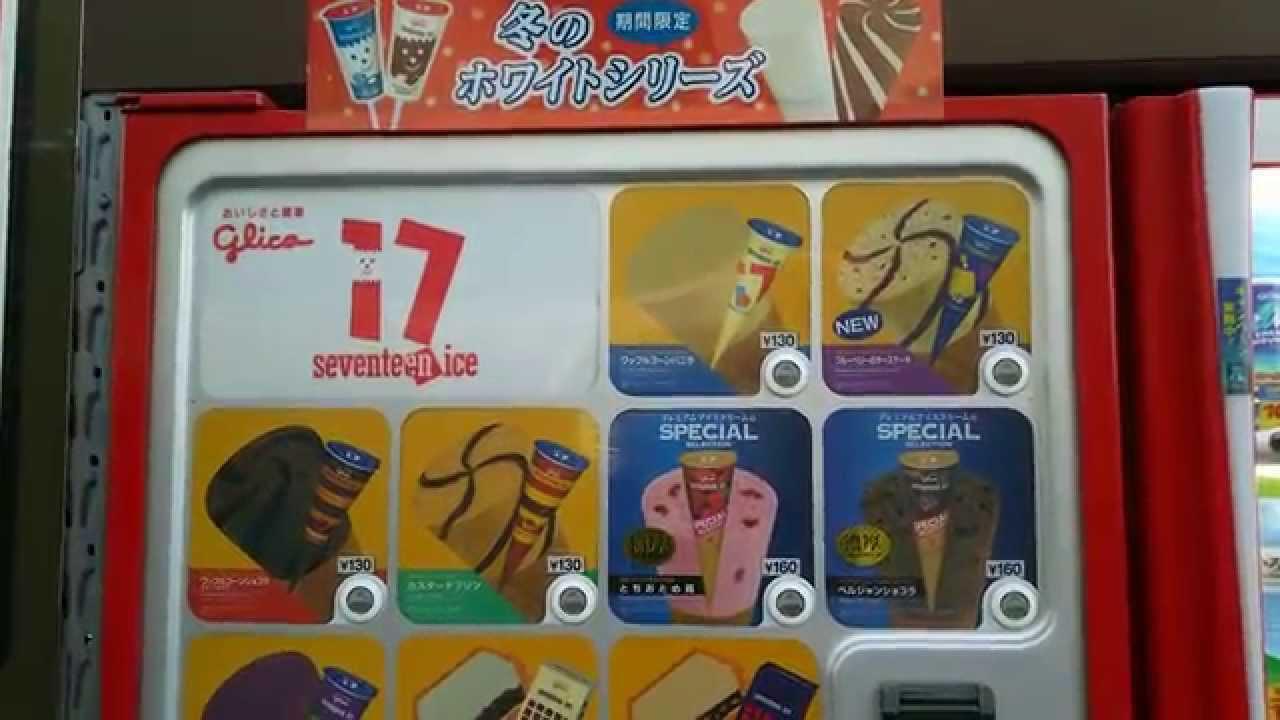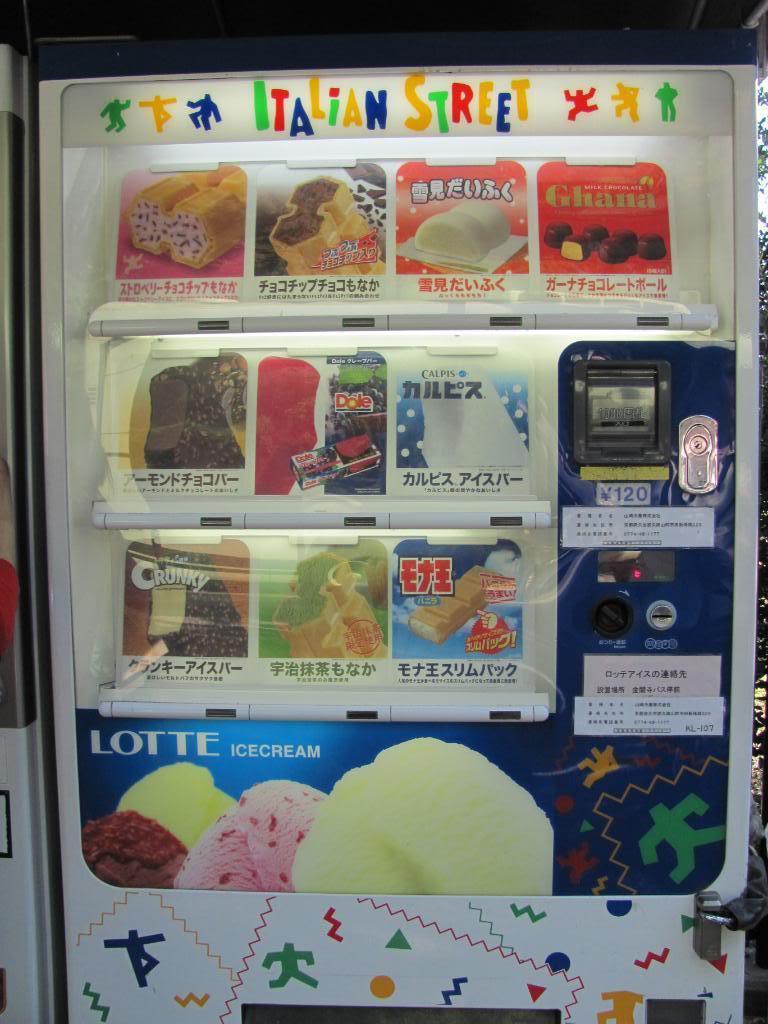The first image is the image on the left, the second image is the image on the right. For the images shown, is this caption "The dispensing port of the vending machine in the image on the right is oval." true? Answer yes or no. No. 